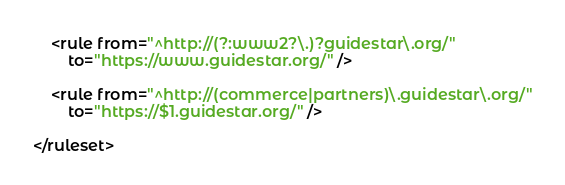<code> <loc_0><loc_0><loc_500><loc_500><_XML_>
	<rule from="^http://(?:www2?\.)?guidestar\.org/"
		to="https://www.guidestar.org/" />

	<rule from="^http://(commerce|partners)\.guidestar\.org/"
		to="https://$1.guidestar.org/" />

</ruleset>
</code> 